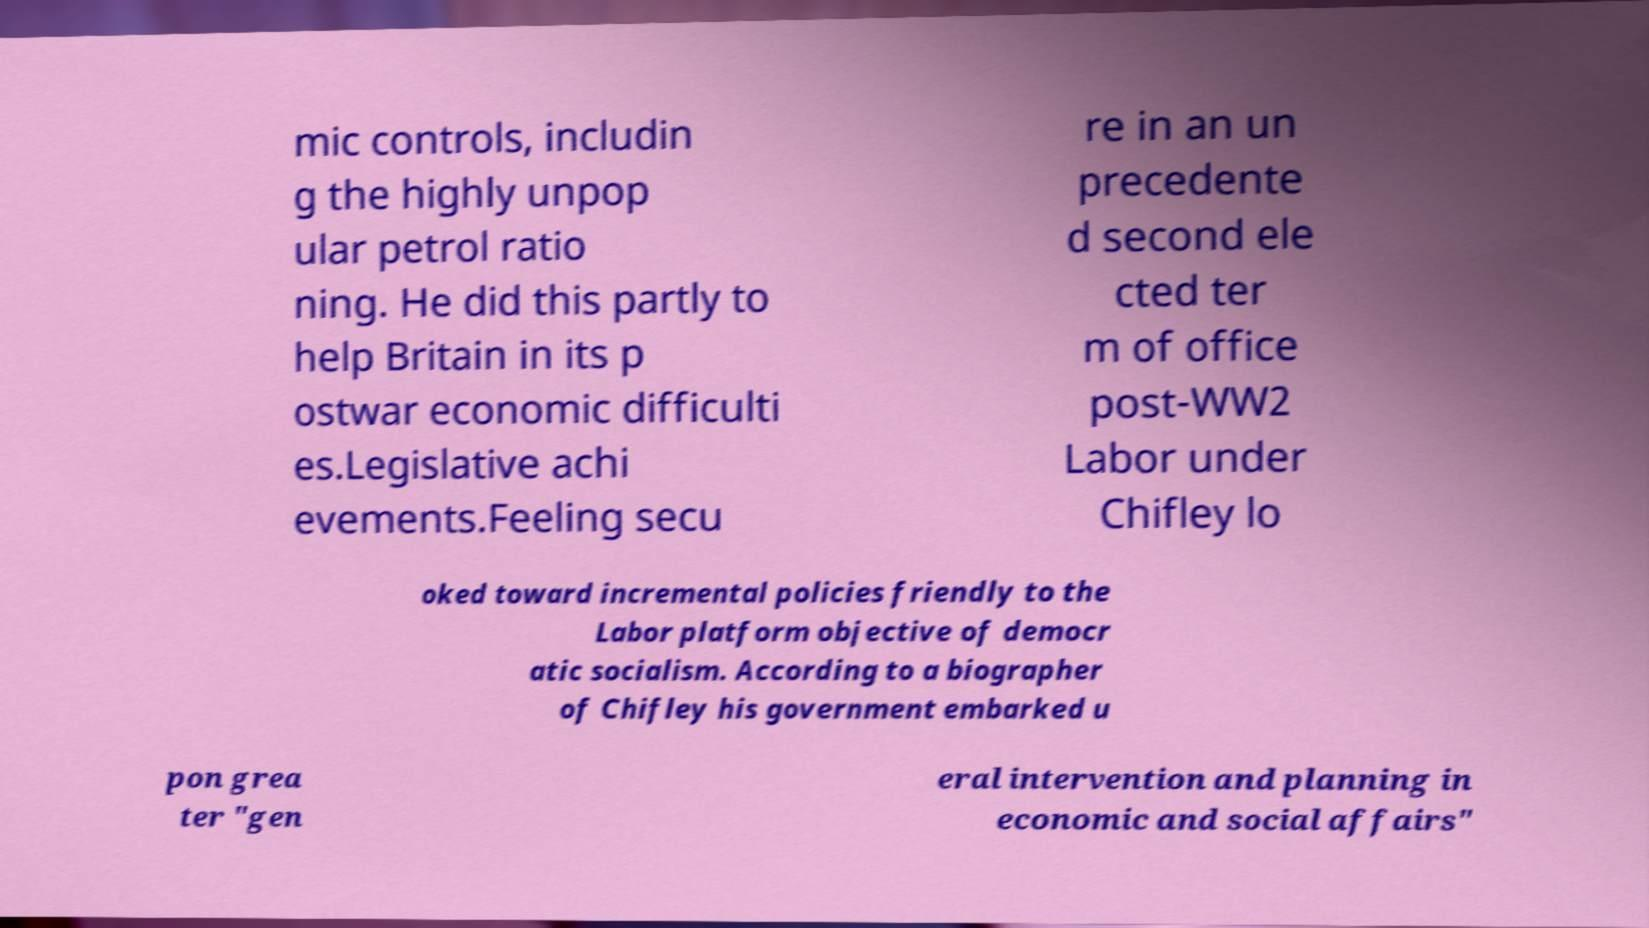Please read and relay the text visible in this image. What does it say? mic controls, includin g the highly unpop ular petrol ratio ning. He did this partly to help Britain in its p ostwar economic difficulti es.Legislative achi evements.Feeling secu re in an un precedente d second ele cted ter m of office post-WW2 Labor under Chifley lo oked toward incremental policies friendly to the Labor platform objective of democr atic socialism. According to a biographer of Chifley his government embarked u pon grea ter "gen eral intervention and planning in economic and social affairs" 